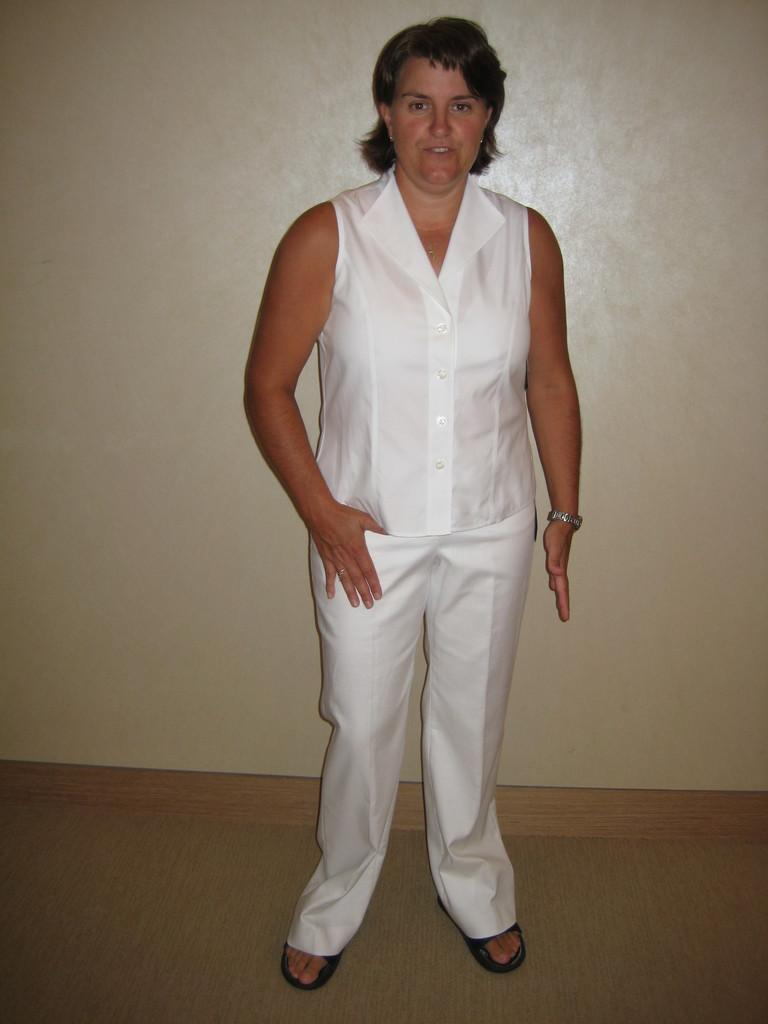Who is present in the image? There is a woman in the image. What is the woman doing in the image? The woman is standing. What is the woman wearing in the image? The woman is wearing a white dress. What can be seen behind the woman in the image? There is a wall behind the woman. What type of pet is sitting next to the woman in the image? There is no pet present in the image; only the woman and the wall are visible. 